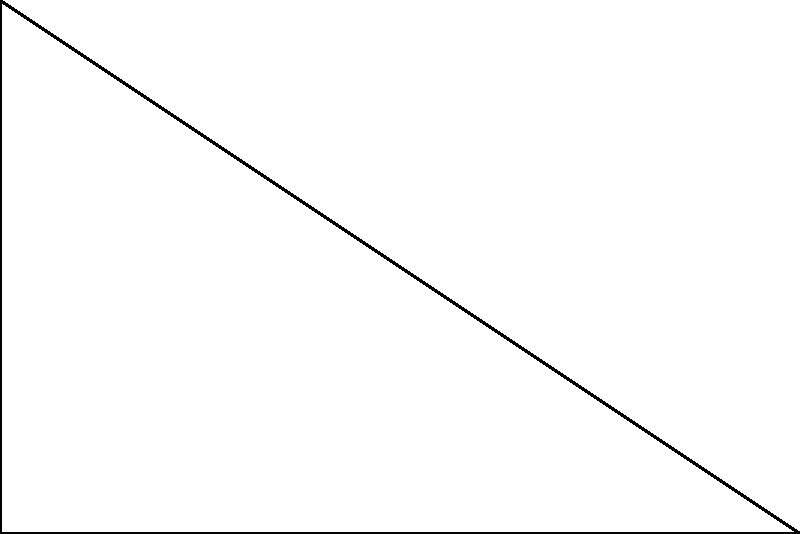As you redesign the common area of your B&B to maximize sunlight, you're considering the placement of a large window. The window forms a right triangle with dimensions 3m wide and 2m high. If the sun's rays make an angle $\theta$ with the horizontal, what should $\theta$ be to maximize the sunlight entering perpendicular to the window? Express your answer in degrees, rounded to the nearest whole number. To maximize sunlight entering perpendicular to the window, we need to find the angle at which the sun's rays are perpendicular to the hypotenuse of the right triangle formed by the window.

Step 1: Determine the vector representing the window's hypotenuse.
The window vector $\vec{v} = (3, 2)$

Step 2: Find the normal vector to the window.
The normal vector $\vec{n}$ is perpendicular to $\vec{v}$. We can rotate $\vec{v}$ by 90° to get $\vec{n}$:
$\vec{n} = (-2, 3)$

Step 3: Calculate the angle between the normal vector and the vertical.
We can use the dot product of $\vec{n}$ and the unit vertical vector $\hat{j} = (0, 1)$:

$\cos \phi = \frac{\vec{n} \cdot \hat{j}}{|\vec{n}||\hat{j}|} = \frac{3}{\sqrt{(-2)^2 + 3^2}} = \frac{3}{\sqrt{13}}$

$\phi = \arccos(\frac{3}{\sqrt{13}})$

Step 4: Calculate $\theta$, which is the complement of $\phi$:
$\theta = 90° - \phi = 90° - \arccos(\frac{3}{\sqrt{13}})$

Step 5: Convert to degrees and round to the nearest whole number:
$\theta \approx 56°$

This angle ensures that the sun's rays are perpendicular to the window's surface, maximizing the sunlight entering the common area.
Answer: 56° 